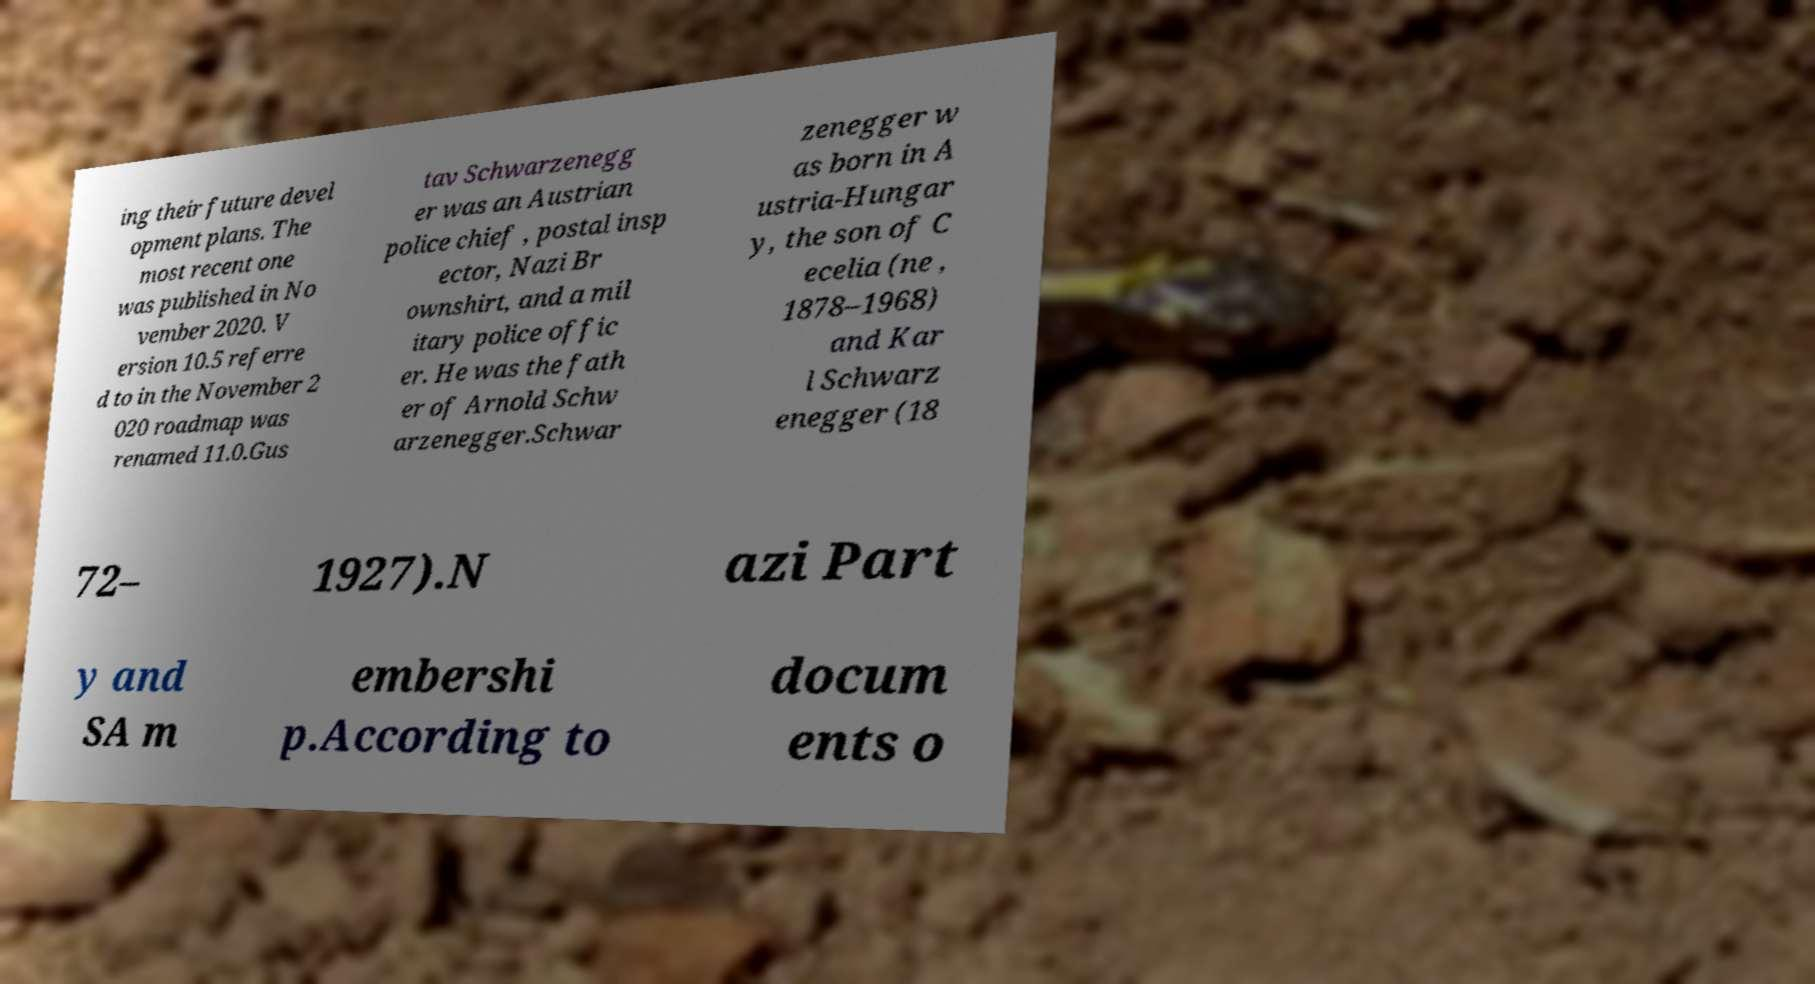Please read and relay the text visible in this image. What does it say? ing their future devel opment plans. The most recent one was published in No vember 2020. V ersion 10.5 referre d to in the November 2 020 roadmap was renamed 11.0.Gus tav Schwarzenegg er was an Austrian police chief , postal insp ector, Nazi Br ownshirt, and a mil itary police offic er. He was the fath er of Arnold Schw arzenegger.Schwar zenegger w as born in A ustria-Hungar y, the son of C ecelia (ne , 1878–1968) and Kar l Schwarz enegger (18 72– 1927).N azi Part y and SA m embershi p.According to docum ents o 